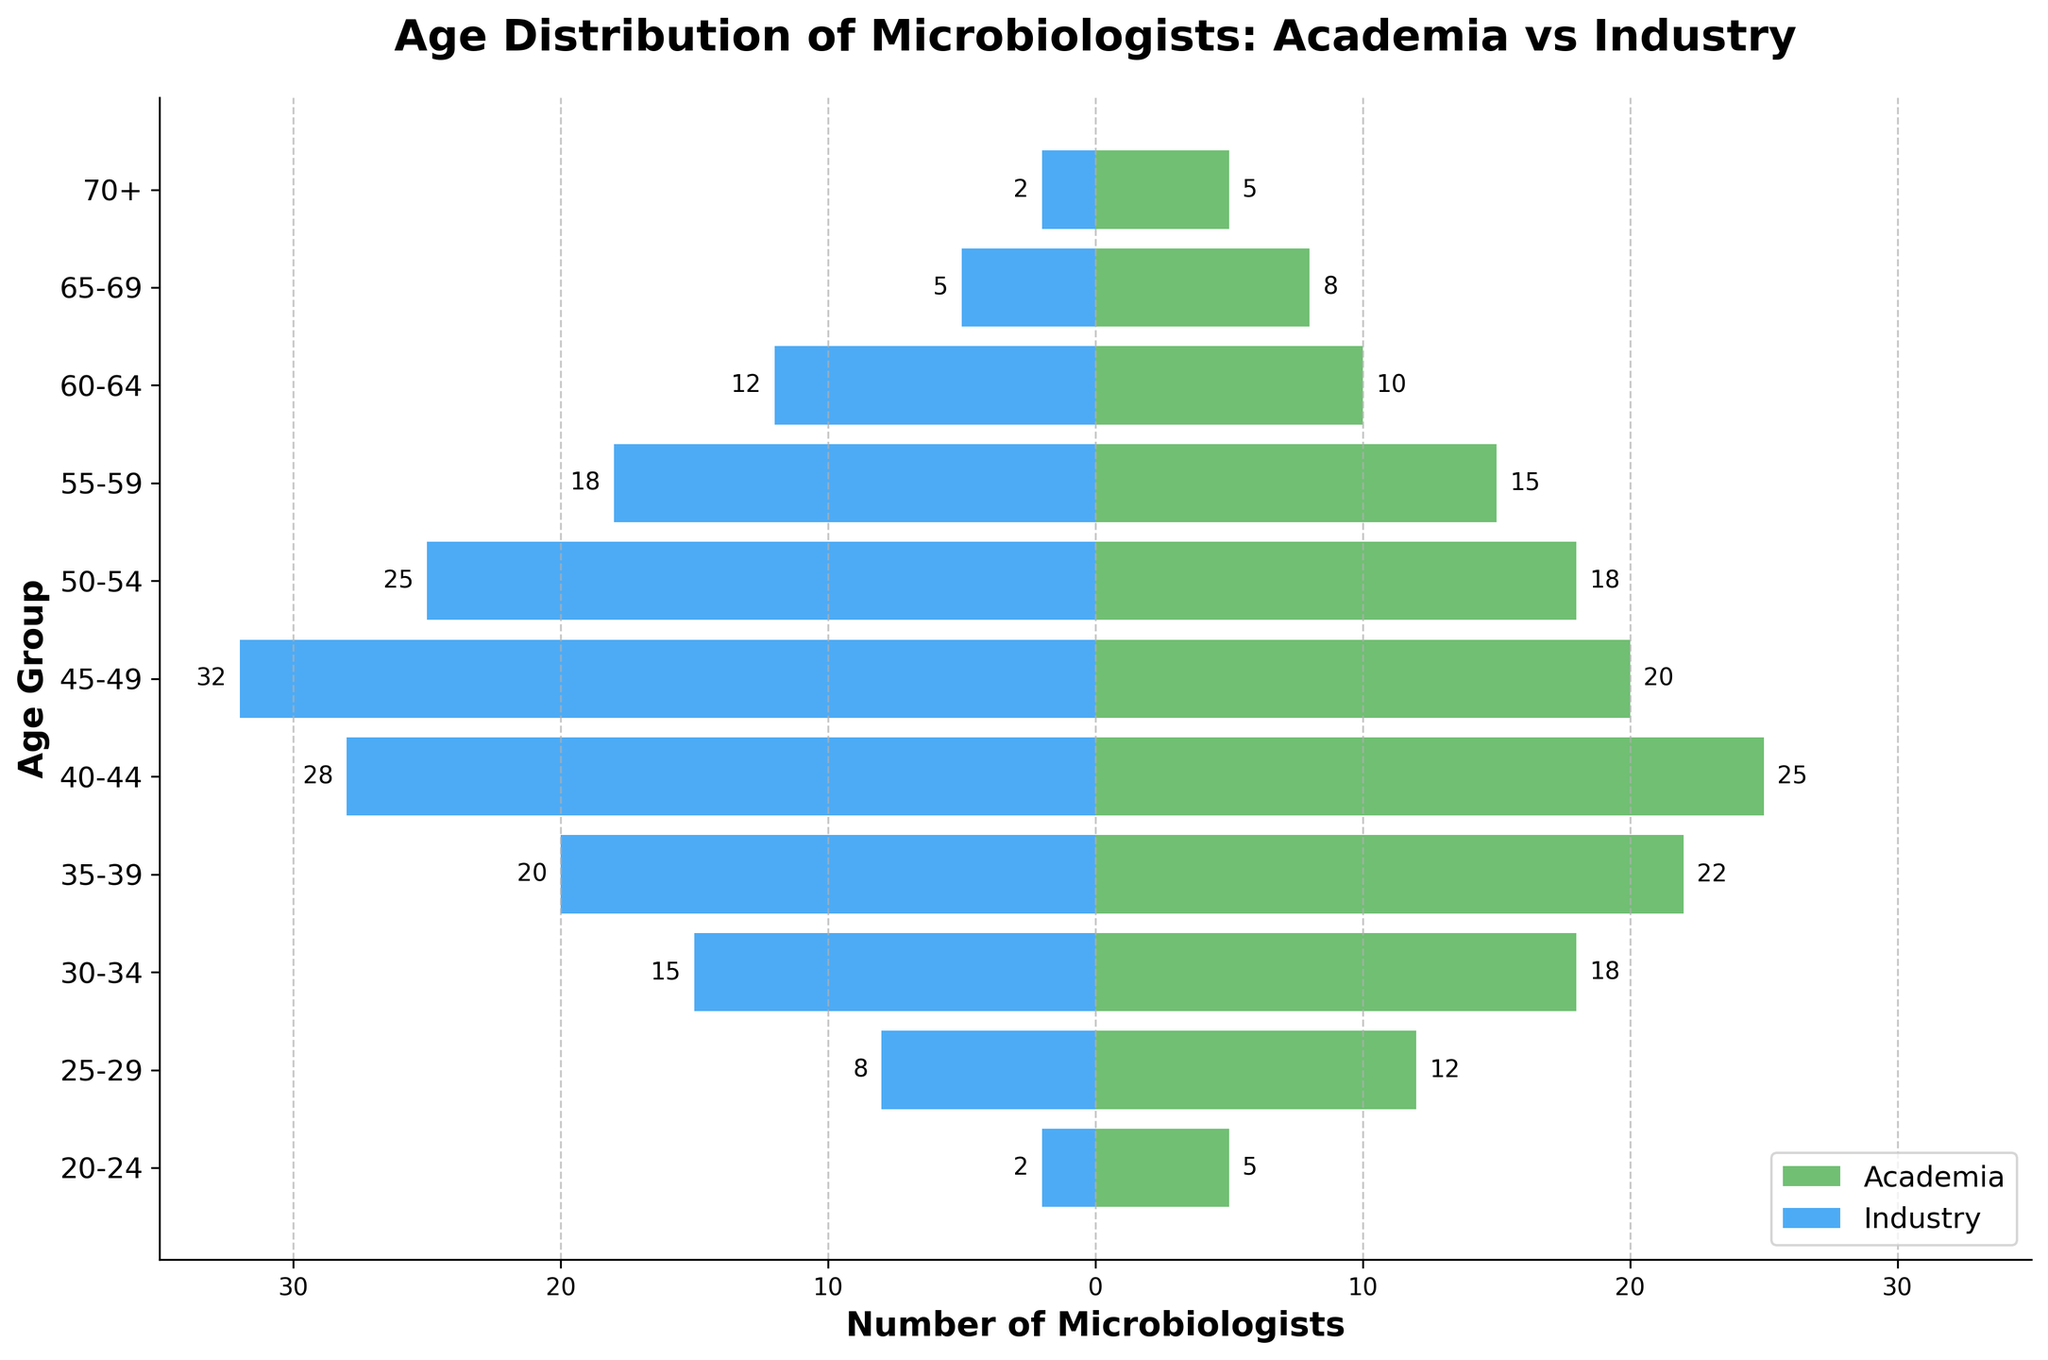What is the title of the figure? The title of the figure is typically found at the top of the chart, written in a larger font. In this case, it reads "Age Distribution of Microbiologists: Academia vs Industry".
Answer: Age Distribution of Microbiologists: Academia vs Industry What are the age groups represented in the figure? The age groups are represented on the y-axis with labels next to the horizontal bars. The age groups are "20-24", "25-29", "30-34", "35-39", "40-44", "45-49", "50-54", "55-59", "60-64", "65-69", and "70+".
Answer: 20-24, 25-29, 30-34, 35-39, 40-44, 45-49, 50-54, 55-59, 60-64, 65-69, 70+ How many microbiologists aged 35-39 are working in academia? Look at the horizontal bar corresponding to the age group "35-39" on the figure, and note the value labeled on that bar for academia. In this case, the figure shows that there are 22 microbiologists in academia aged 35-39.
Answer: 22 How does the number of microbiologists aged 40-44 in academia compare to those in industry? Find the horizontal bars for the age group "40-44" and observe their lengths and labels. In academia, there are 25, and in industry, there are 28. Comparing the two, 25 is less than 28.
Answer: Less What is the total number of microbiologists aged 50-54 in both academia and industry? Find the horizontal bars for the age group "50-54" and add the numbers labeled on them. In academia, there are 18, and in industry, there are 25. So, 18 + 25 = 43.
Answer: 43 At which age group do we see the maximum number of microbiologists in industry? Inspect all the blue bars on the left side of the pyramid to see which one extends the farthest. The maximum number is 32 in the age group "45-49".
Answer: 45-49 Which age group has the fewest microbiologists in academia? Look for the shortest green bar on the right side of the pyramid, which belongs to the "20-24" and "70+" age groups, both with 5 microbiologists.
Answer: 20-24 and 70+ What is the average number of microbiologists aged 25-29 in both academia and industry? First, find the numbers for the "25-29" age group, which are 12 in academia and 8 in industry. Calculate their average: (12 + 8) / 2 = 10.
Answer: 10 Which age group has more microbiologists in academia than in industry by the largest margin? Compare the green and blue bars for each age group and note the differences. The largest positive difference (academia - industry) is seen for the "20-24" age group: 5 (academia) - 2 (industry) = 3.
Answer: 20-24 Which age group has an equal number of microbiologists in both academia and industry? None of the age groups have bars of equal length on either side, meaning there is no age group with the same number of microbiologists in both fields.
Answer: None 